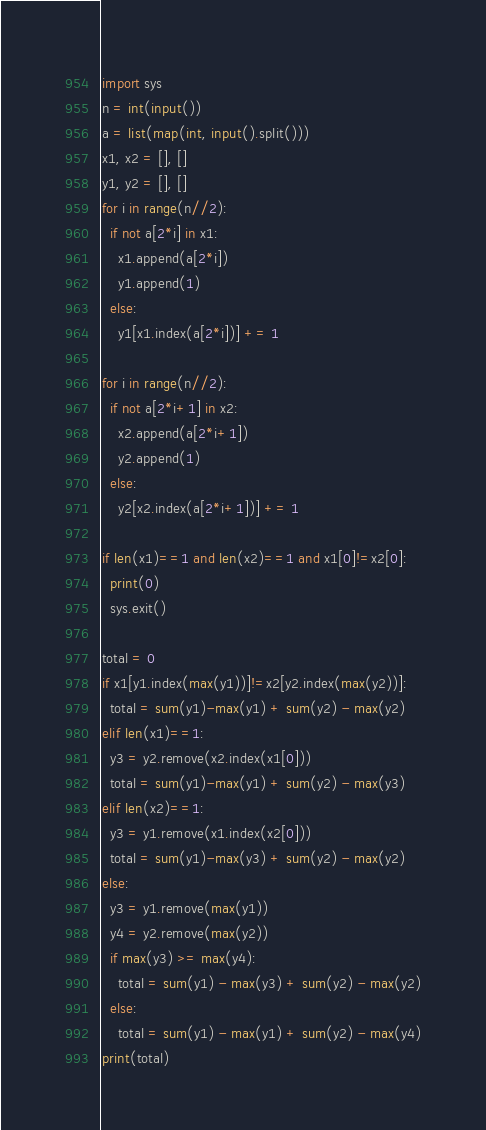<code> <loc_0><loc_0><loc_500><loc_500><_Python_>import sys
n = int(input())
a = list(map(int, input().split()))
x1, x2 = [], []
y1, y2 = [], []
for i in range(n//2):
  if not a[2*i] in x1:
    x1.append(a[2*i])
    y1.append(1)
  else:
    y1[x1.index(a[2*i])] += 1

for i in range(n//2):
  if not a[2*i+1] in x2:
    x2.append(a[2*i+1])
    y2.append(1)
  else:
    y2[x2.index(a[2*i+1])] += 1

if len(x1)==1 and len(x2)==1 and x1[0]!=x2[0]:
  print(0)
  sys.exit()

total = 0
if x1[y1.index(max(y1))]!=x2[y2.index(max(y2))]:
  total = sum(y1)-max(y1) + sum(y2) - max(y2)
elif len(x1)==1:
  y3 = y2.remove(x2.index(x1[0]))
  total = sum(y1)-max(y1) + sum(y2) - max(y3)
elif len(x2)==1:
  y3 = y1.remove(x1.index(x2[0]))
  total = sum(y1)-max(y3) + sum(y2) - max(y2)
else:
  y3 = y1.remove(max(y1))
  y4 = y2.remove(max(y2))
  if max(y3) >= max(y4):
    total = sum(y1) - max(y3) + sum(y2) - max(y2)
  else:
    total = sum(y1) - max(y1) + sum(y2) - max(y4)
print(total)</code> 